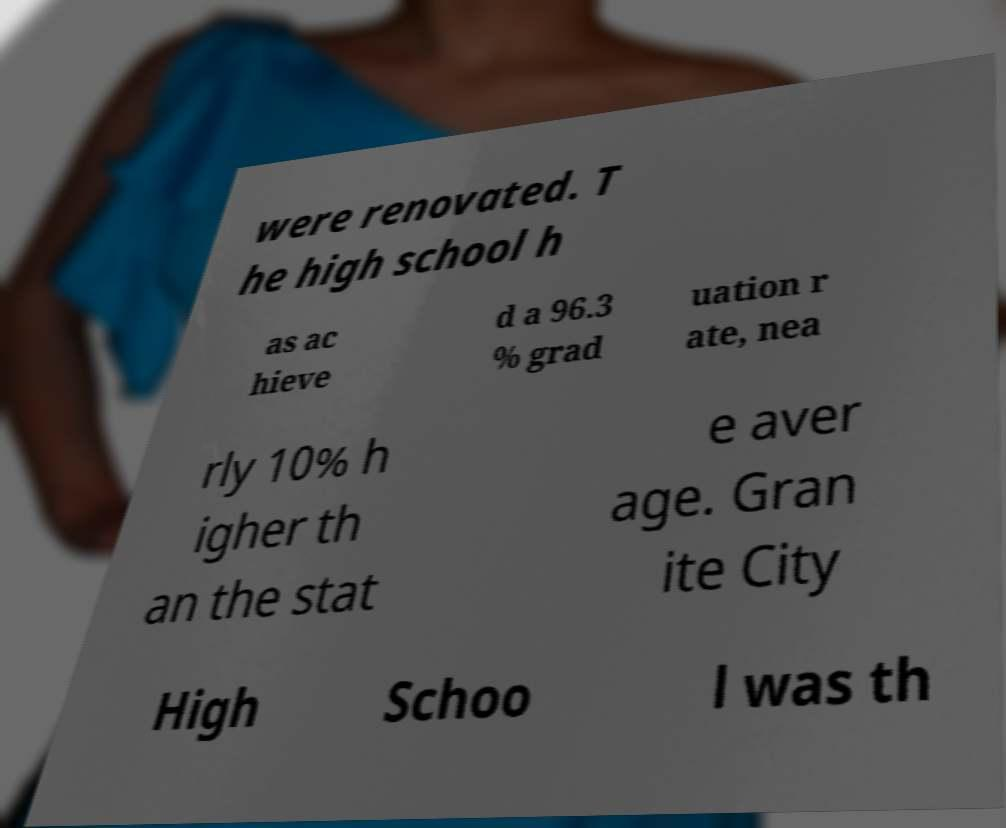I need the written content from this picture converted into text. Can you do that? were renovated. T he high school h as ac hieve d a 96.3 % grad uation r ate, nea rly 10% h igher th an the stat e aver age. Gran ite City High Schoo l was th 